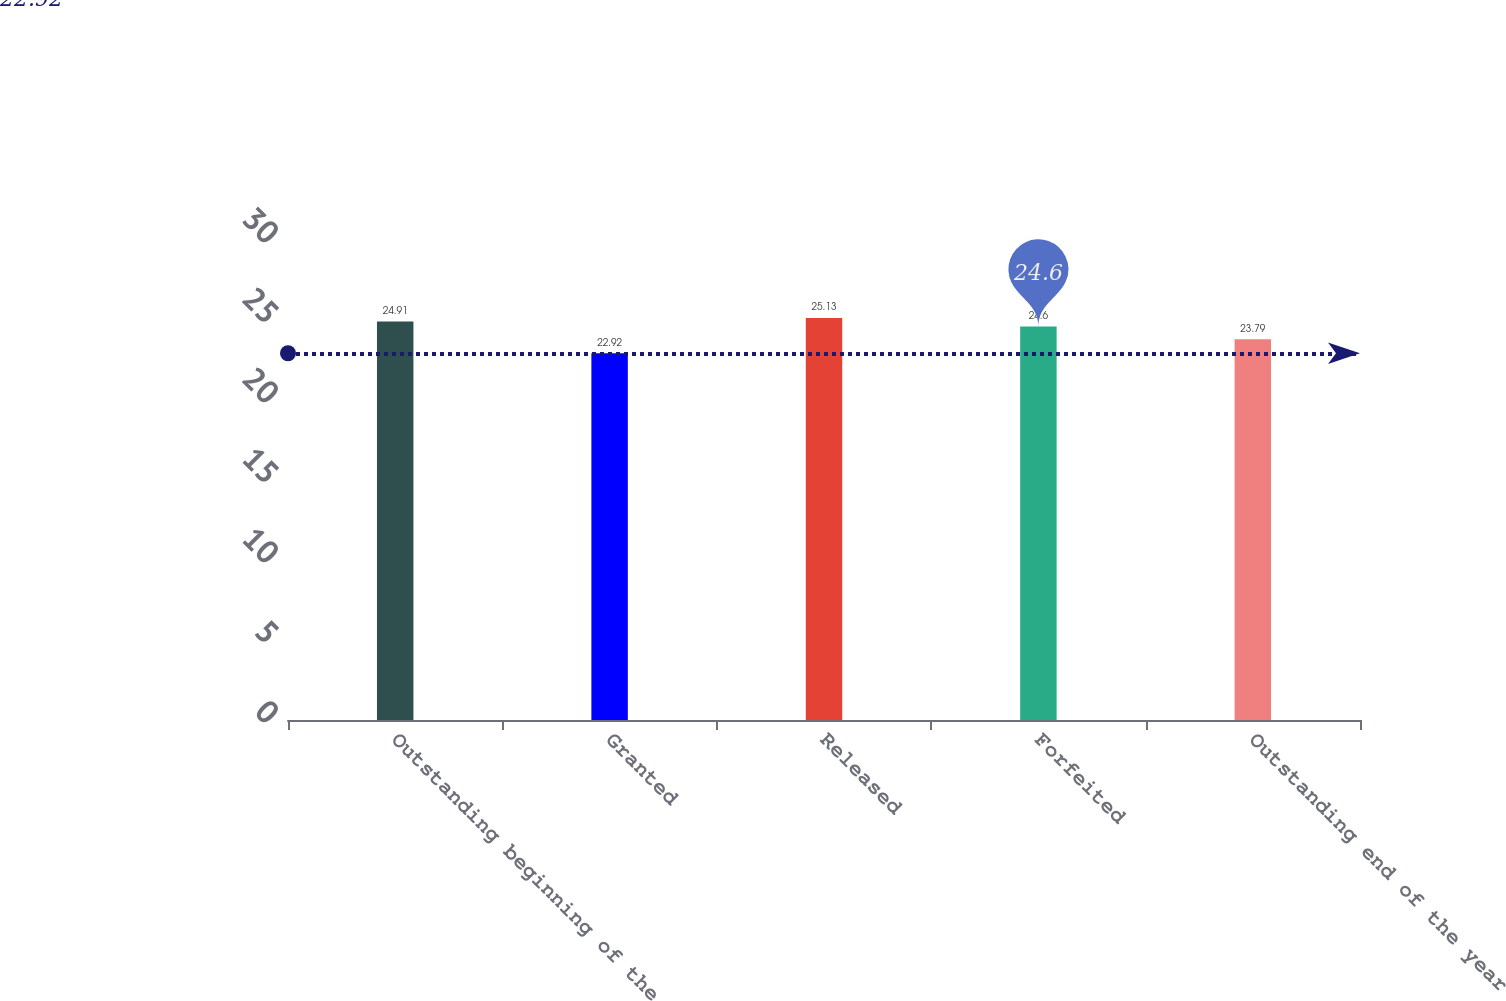Convert chart. <chart><loc_0><loc_0><loc_500><loc_500><bar_chart><fcel>Outstanding beginning of the<fcel>Granted<fcel>Released<fcel>Forfeited<fcel>Outstanding end of the year<nl><fcel>24.91<fcel>22.92<fcel>25.13<fcel>24.6<fcel>23.79<nl></chart> 